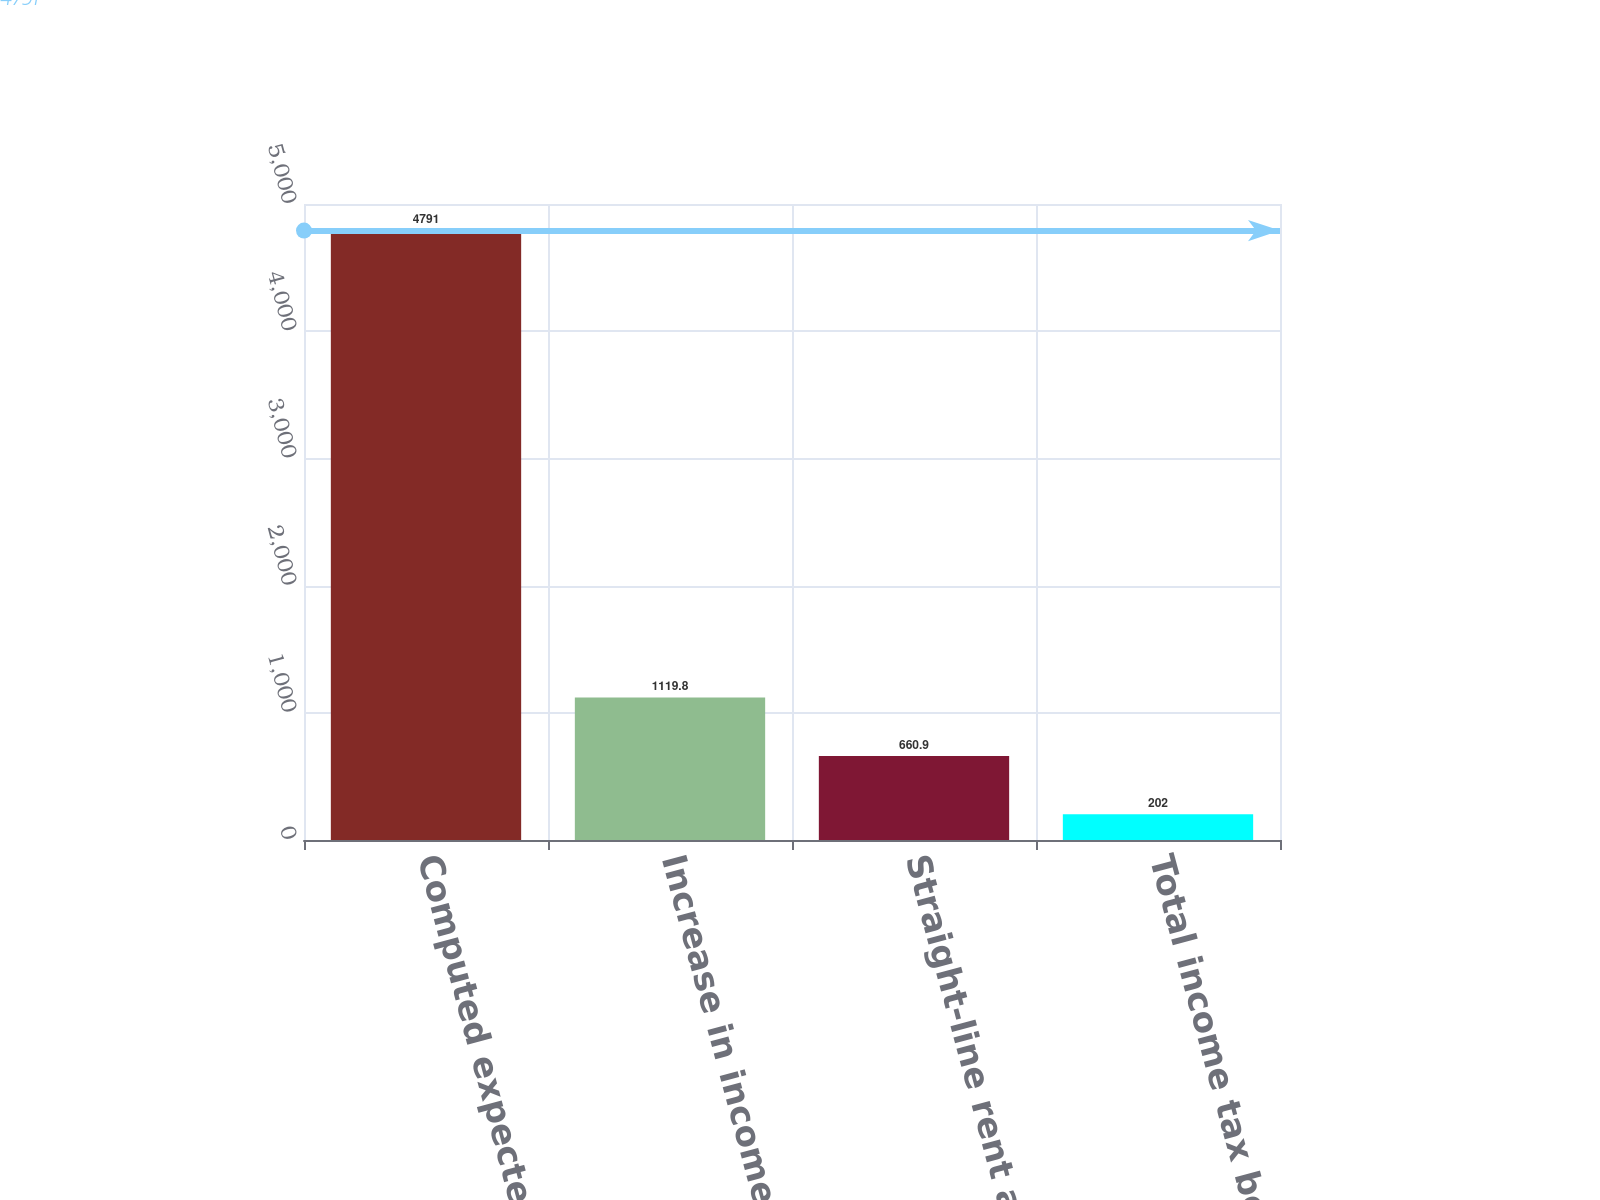<chart> <loc_0><loc_0><loc_500><loc_500><bar_chart><fcel>Computed expected tax benefit<fcel>Increase in income tax<fcel>Straight-line rent and all<fcel>Total income tax benefit<nl><fcel>4791<fcel>1119.8<fcel>660.9<fcel>202<nl></chart> 